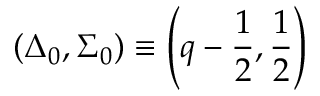<formula> <loc_0><loc_0><loc_500><loc_500>( \Delta _ { 0 } , \Sigma _ { 0 } ) \equiv \left ( q - \frac { 1 } { 2 } , \frac { 1 } { 2 } \right )</formula> 